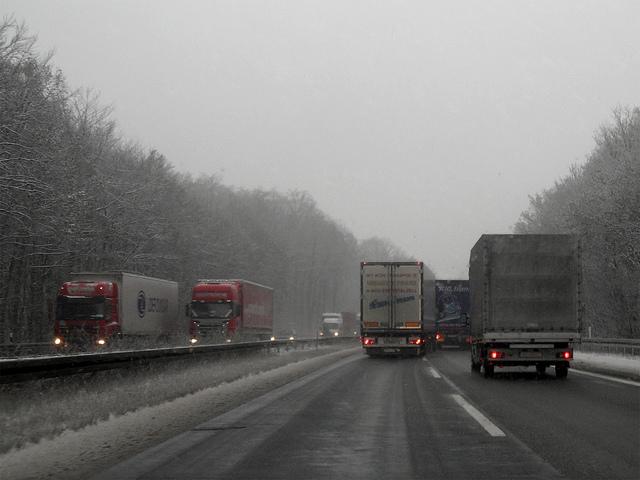How many trucks are not facing the camera?
Write a very short answer. 3. Is the sun out and shining?
Concise answer only. No. How many lanes are on this highway?
Keep it brief. 2. 